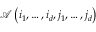<formula> <loc_0><loc_0><loc_500><loc_500>\mathcal { A } \left ( i _ { 1 } , \dots , i _ { d } , j _ { 1 } , \dots , j _ { d } \right )</formula> 